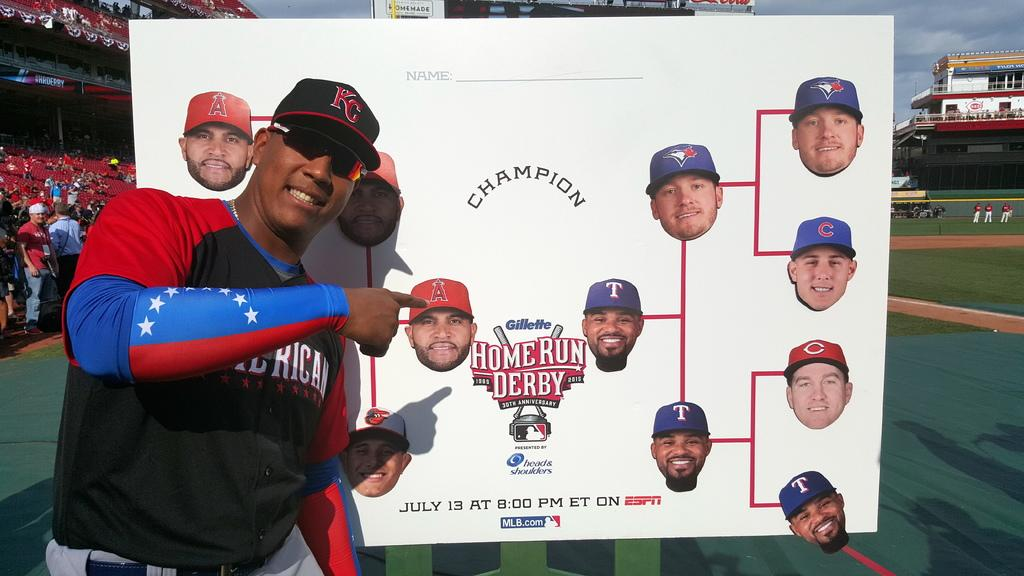<image>
Share a concise interpretation of the image provided. a home run derby sign that is next to a man 